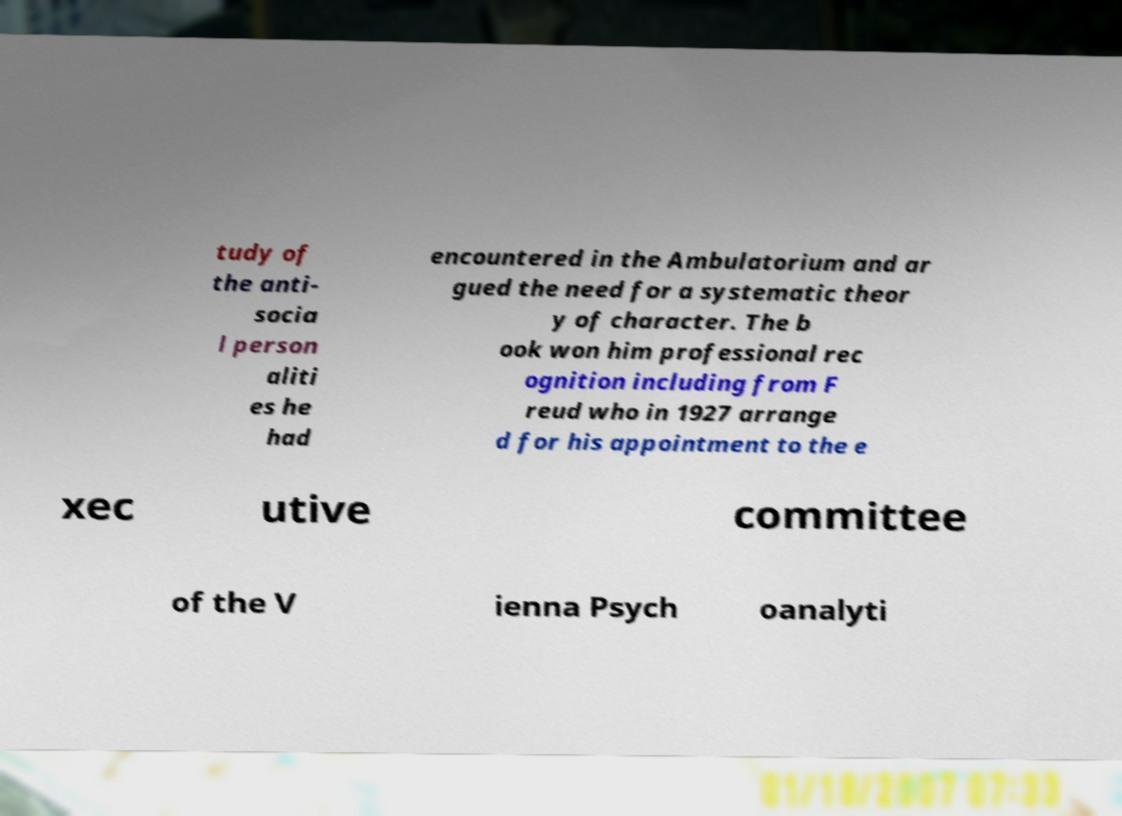Could you extract and type out the text from this image? tudy of the anti- socia l person aliti es he had encountered in the Ambulatorium and ar gued the need for a systematic theor y of character. The b ook won him professional rec ognition including from F reud who in 1927 arrange d for his appointment to the e xec utive committee of the V ienna Psych oanalyti 